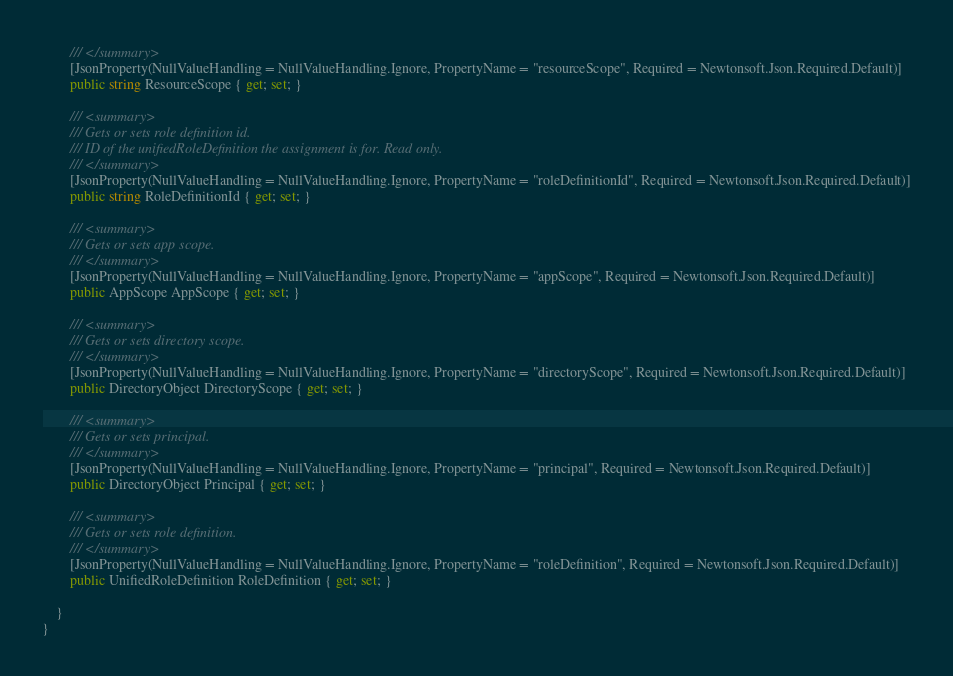Convert code to text. <code><loc_0><loc_0><loc_500><loc_500><_C#_>        /// </summary>
        [JsonProperty(NullValueHandling = NullValueHandling.Ignore, PropertyName = "resourceScope", Required = Newtonsoft.Json.Required.Default)]
        public string ResourceScope { get; set; }
    
        /// <summary>
        /// Gets or sets role definition id.
        /// ID of the unifiedRoleDefinition the assignment is for. Read only.
        /// </summary>
        [JsonProperty(NullValueHandling = NullValueHandling.Ignore, PropertyName = "roleDefinitionId", Required = Newtonsoft.Json.Required.Default)]
        public string RoleDefinitionId { get; set; }
    
        /// <summary>
        /// Gets or sets app scope.
        /// </summary>
        [JsonProperty(NullValueHandling = NullValueHandling.Ignore, PropertyName = "appScope", Required = Newtonsoft.Json.Required.Default)]
        public AppScope AppScope { get; set; }
    
        /// <summary>
        /// Gets or sets directory scope.
        /// </summary>
        [JsonProperty(NullValueHandling = NullValueHandling.Ignore, PropertyName = "directoryScope", Required = Newtonsoft.Json.Required.Default)]
        public DirectoryObject DirectoryScope { get; set; }
    
        /// <summary>
        /// Gets or sets principal.
        /// </summary>
        [JsonProperty(NullValueHandling = NullValueHandling.Ignore, PropertyName = "principal", Required = Newtonsoft.Json.Required.Default)]
        public DirectoryObject Principal { get; set; }
    
        /// <summary>
        /// Gets or sets role definition.
        /// </summary>
        [JsonProperty(NullValueHandling = NullValueHandling.Ignore, PropertyName = "roleDefinition", Required = Newtonsoft.Json.Required.Default)]
        public UnifiedRoleDefinition RoleDefinition { get; set; }
    
    }
}

</code> 